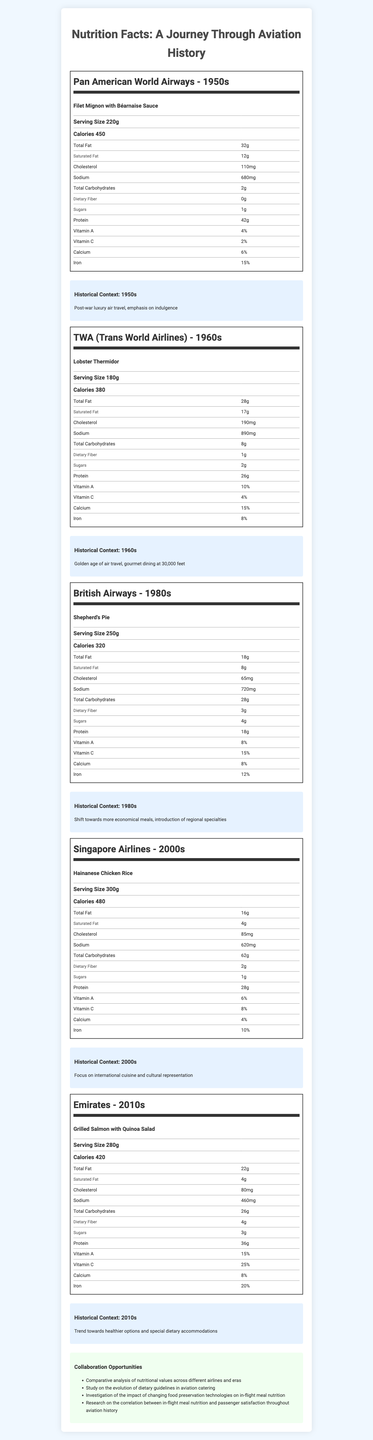what is the serving size of the Filet Mignon with Béarnaise Sauce? The serving size is specifically listed as 220g in the nutritional label for Pan American World Airways' meal from the 1950s.
Answer: 220g which meal has the highest amount of protein? A. Filet Mignon with Béarnaise Sauce B. Lobster Thermidor C. Hainanese Chicken Rice D. Grilled Salmon with Quinoa Salad Grilled Salmon with Quinoa Salad has 36g of protein, more than the other listed options.
Answer: D which era focused on the introduction of regional specialties? A. 1950s B. 1960s C. 1980s D. 2010s The 1980s saw a shift towards more economical meals and the introduction of regional specialties.
Answer: C how many calories are in the Hainanese Chicken Rice? Hainanese Chicken Rice, served by Singapore Airlines in the 2000s, contains 480 calories as shown in its nutritional label.
Answer: 480 did the Shepherd's Pie contain more than 20g of protein? The Shepherd's Pie contains 18g of protein, which is less than 20g.
Answer: No which meal from the 2010s has a higher level of dietary fiber? According to the nutritional information, the Grilled Salmon with Quinoa Salad has 4g of dietary fiber which is higher than other meals listed.
Answer: Grilled Salmon with Quinoa Salad what is a significant trend in aviation meals during the 1950s-60s? The nutritional trends section highlights that meals in the 1950s-60s were high in calories, fat, and cholesterol, with luxury ingredients prioritized over nutritional value.
Answer: High in calories, fat, and cholesterol; luxury ingredients prioritized over nutritional value how has in-flight meal nutrition changed from the 1980s to the 2010s? The historical trends show a shift from moderately high sodium and carbohydrates in the 1980s to a focus on lean proteins, complex carbohydrates, and vegetables in the 2010s.
Answer: Focus shifted from moderately high sodium and carbohydrates to increased lean proteins and vegetables did the meal served by TWA in the 1960s contain more than 1000mg of sodium? The Lobster Thermidor served by TWA in the 1960s contains 890mg of sodium, which is less than 1000mg.
Answer: No which airline offered a meal with the lowest amount of sugars? A. Pan American World Airways B. TWA C. British Airways D. Emirates Pan American World Airways' Filet Mignon with Béarnaise Sauce has only 1g of sugars, which is the lowest among the options listed.
Answer: A describe the main idea of the document The document highlights how the nutritional content of in-flight meals has evolved over time, influenced by historical contexts and trends, with a focus on luxury ingredients in earlier decades and healthier options in recent years. It also proposes potential research and collaboration opportunities in understanding these changes.
Answer: The document provides nutrition facts of in-flight meals offered by different airlines from the 1950s to the 2010s, showing changing trends in aviation catering, historical contexts, and collaboration opportunities. which meal has the highest amount of sodium? Although specific sodium values are listed for each meal, the nutrient content alone does not indicate the meal as served; more context like accompanying sides or beverages isn't provided.
Answer: Not enough information 